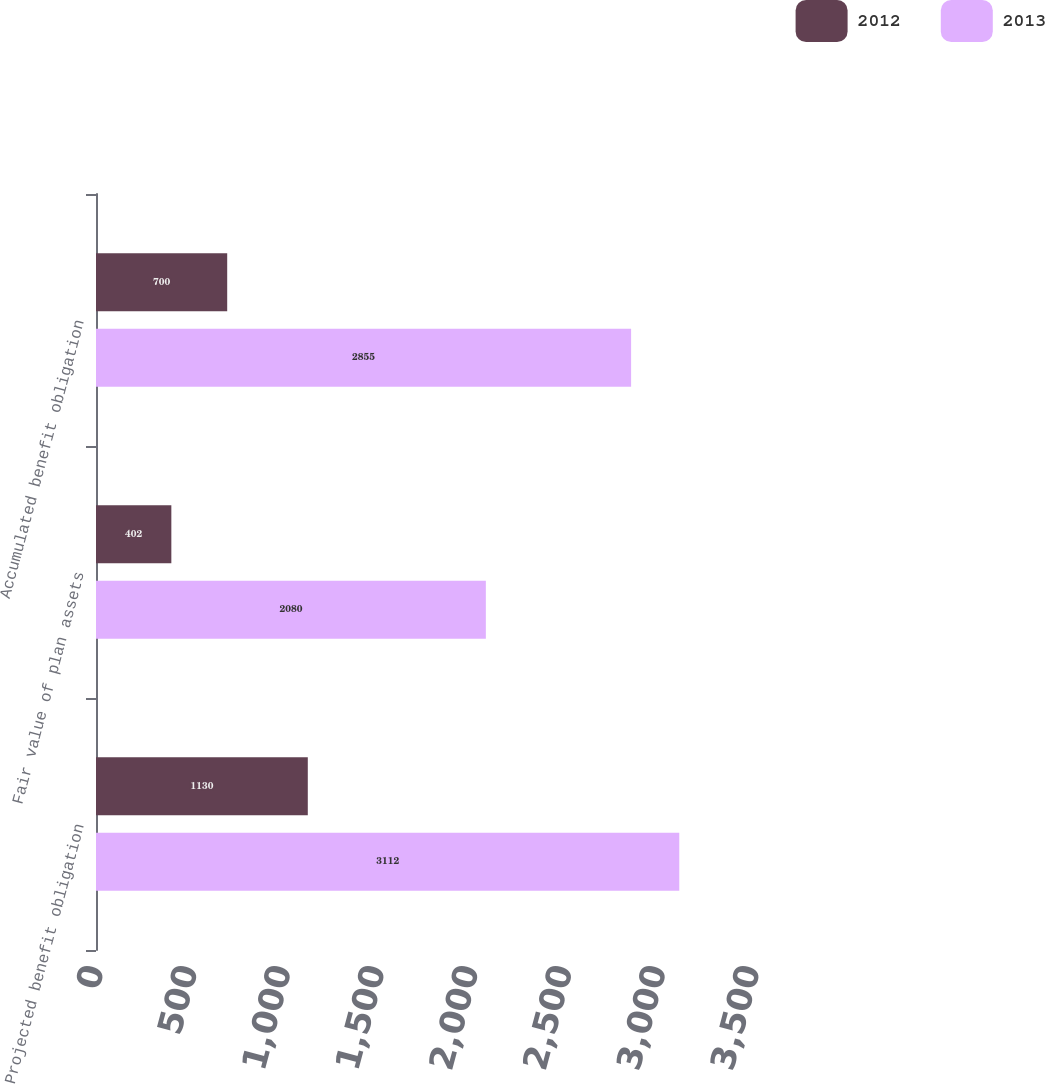Convert chart to OTSL. <chart><loc_0><loc_0><loc_500><loc_500><stacked_bar_chart><ecel><fcel>Projected benefit obligation<fcel>Fair value of plan assets<fcel>Accumulated benefit obligation<nl><fcel>2012<fcel>1130<fcel>402<fcel>700<nl><fcel>2013<fcel>3112<fcel>2080<fcel>2855<nl></chart> 